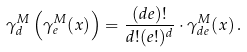<formula> <loc_0><loc_0><loc_500><loc_500>\gamma _ { d } ^ { M } \left ( \gamma _ { e } ^ { M } ( x ) \right ) = \frac { ( d e ) ! } { d ! ( e ! ) ^ { d } } \cdot \gamma _ { d e } ^ { M } ( x ) \, .</formula> 